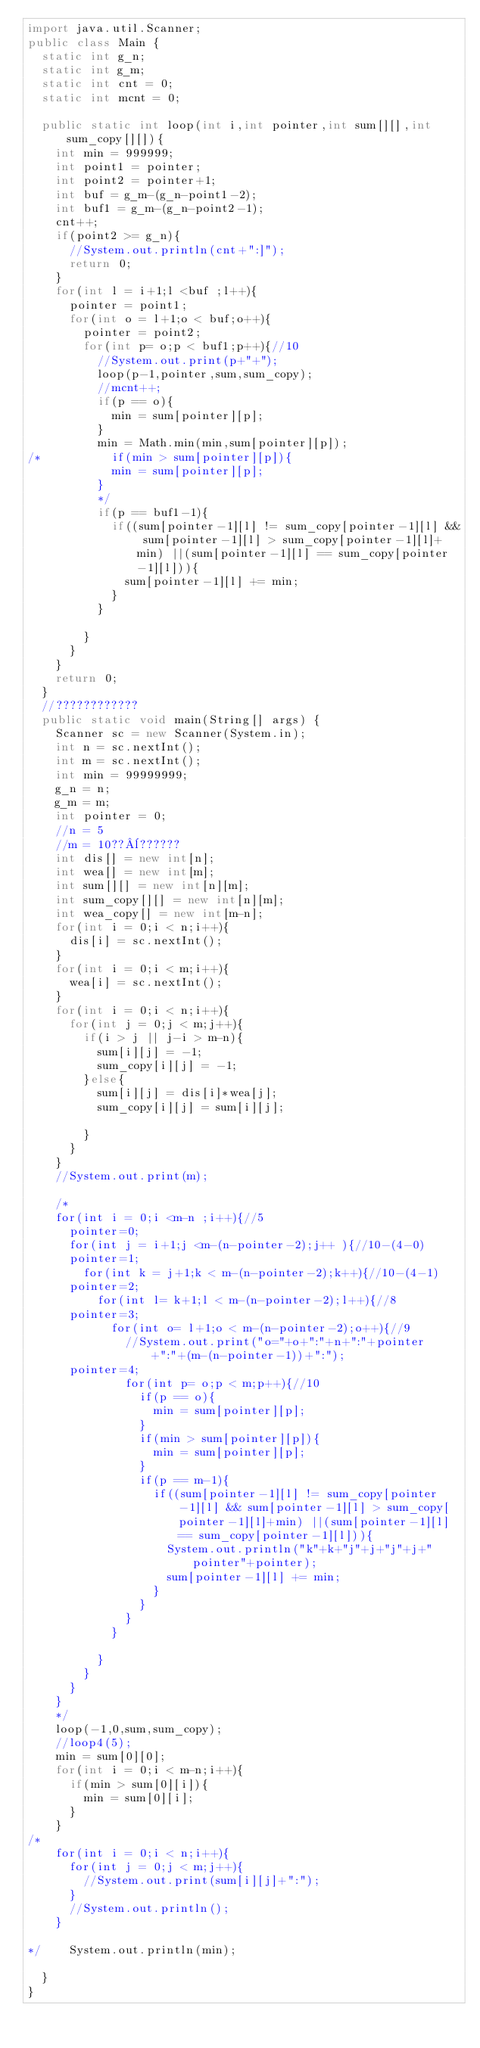Convert code to text. <code><loc_0><loc_0><loc_500><loc_500><_Java_>import java.util.Scanner;
public class Main {
	static int g_n;
	static int g_m;
	static int cnt = 0;
	static int mcnt = 0;

	public static int loop(int i,int pointer,int sum[][],int sum_copy[][]){
		int min = 999999;
		int point1 = pointer;
		int point2 = pointer+1;
		int buf = g_m-(g_n-point1-2);
		int buf1 = g_m-(g_n-point2-1);
		cnt++;
		if(point2 >= g_n){
			//System.out.println(cnt+":]");
			return 0;
		}
		for(int l = i+1;l <buf ;l++){
			pointer = point1;
			for(int o = l+1;o < buf;o++){
				pointer = point2;
				for(int p= o;p < buf1;p++){//10
					//System.out.print(p+"+");
					loop(p-1,pointer,sum,sum_copy);
					//mcnt++;
					if(p == o){
						min = sum[pointer][p];
					}
					min = Math.min(min,sum[pointer][p]);
/*					if(min > sum[pointer][p]){
						min = sum[pointer][p];
					}
					*/
					if(p == buf1-1){							
						if((sum[pointer-1][l] != sum_copy[pointer-1][l] && sum[pointer-1][l] > sum_copy[pointer-1][l]+min) ||(sum[pointer-1][l] == sum_copy[pointer-1][l])){
							sum[pointer-1][l] += min; 
						}	
					}
					
				}
			}
		}
		return 0;
	}
	//????????????
	public static void main(String[] args) {
		Scanner sc = new Scanner(System.in);
		int n = sc.nextInt();
		int m = sc.nextInt();
		int min = 99999999;
		g_n = n;
		g_m = m;
		int pointer = 0;
		//n = 5
		//m = 10??¨??????
		int dis[] = new int[n];
		int wea[] = new int[m];
		int sum[][] = new int[n][m];
		int sum_copy[][] = new int[n][m];
		int wea_copy[] = new int[m-n];
		for(int i = 0;i < n;i++){
			dis[i] = sc.nextInt();
		}
		for(int i = 0;i < m;i++){
			wea[i] = sc.nextInt();
		}
		for(int i = 0;i < n;i++){
			for(int j = 0;j < m;j++){
				if(i > j || j-i > m-n){
					sum[i][j] = -1;
					sum_copy[i][j] = -1;
				}else{
					sum[i][j] = dis[i]*wea[j];
					sum_copy[i][j] = sum[i][j];

				}
			}
		}
		//System.out.print(m);
				
		/*
		for(int i = 0;i <m-n ;i++){//5
			pointer=0;
			for(int j = i+1;j <m-(n-pointer-2);j++ ){//10-(4-0)
			pointer=1;
				for(int k = j+1;k < m-(n-pointer-2);k++){//10-(4-1)
			pointer=2;
					for(int l= k+1;l < m-(n-pointer-2);l++){//8
			pointer=3;
						for(int o= l+1;o < m-(n-pointer-2);o++){//9
							//System.out.print("o="+o+":"+n+":"+pointer+":"+(m-(n-pointer-1))+":");
			pointer=4;
							for(int p= o;p < m;p++){//10
								if(p == o){
									min = sum[pointer][p];
								}
								if(min > sum[pointer][p]){
									min = sum[pointer][p];
								}
								if(p == m-1){							
									if((sum[pointer-1][l] != sum_copy[pointer-1][l] && sum[pointer-1][l] > sum_copy[pointer-1][l]+min) ||(sum[pointer-1][l] == sum_copy[pointer-1][l])){
										System.out.println("k"+k+"j"+j+"j"+j+"pointer"+pointer);
										sum[pointer-1][l] += min; 
									}	
								}
							}
						}

					}	
				}
			}
		}
		*/
		loop(-1,0,sum,sum_copy);
		//loop4(5);
		min = sum[0][0];
		for(int i = 0;i < m-n;i++){
			if(min > sum[0][i]){
				min = sum[0][i];
			}
		}
/*
		for(int i = 0;i < n;i++){
			for(int j = 0;j < m;j++){
				//System.out.print(sum[i][j]+":");	
			}
			//System.out.println();
		}	

*/		System.out.println(min);

	}
}</code> 